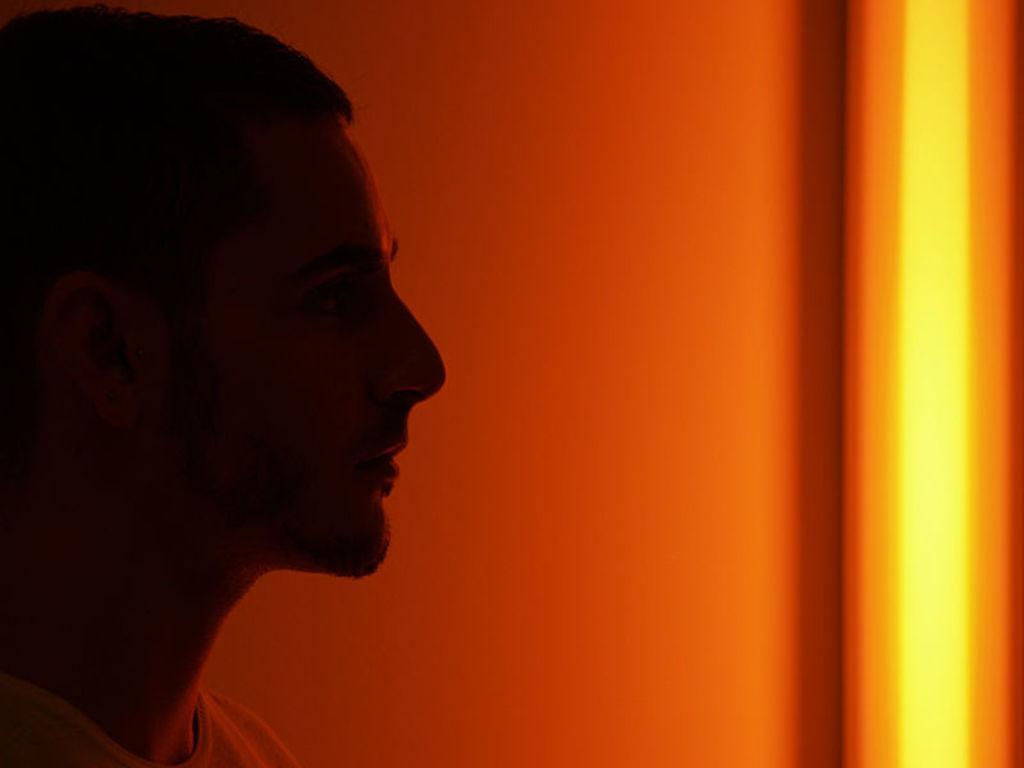Please provide a concise description of this image. On the left we can see a person. On the right there is light. In the middle it is well. 